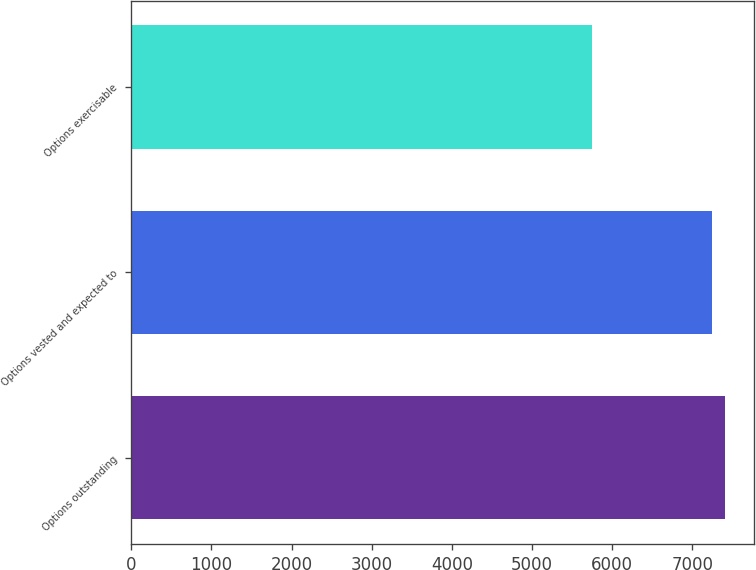Convert chart to OTSL. <chart><loc_0><loc_0><loc_500><loc_500><bar_chart><fcel>Options outstanding<fcel>Options vested and expected to<fcel>Options exercisable<nl><fcel>7402.7<fcel>7242<fcel>5752<nl></chart> 